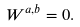<formula> <loc_0><loc_0><loc_500><loc_500>W ^ { a , b } = 0 .</formula> 